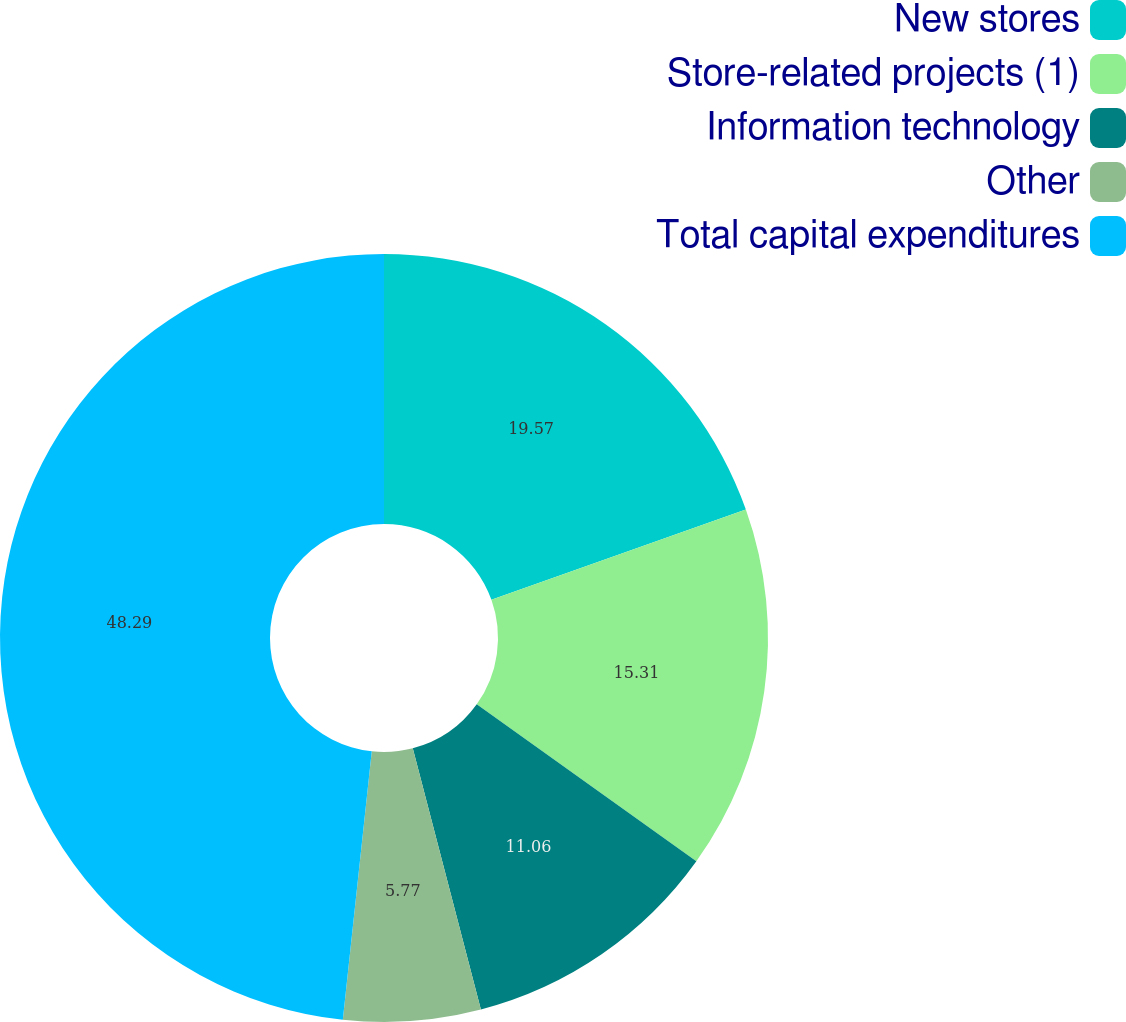<chart> <loc_0><loc_0><loc_500><loc_500><pie_chart><fcel>New stores<fcel>Store-related projects (1)<fcel>Information technology<fcel>Other<fcel>Total capital expenditures<nl><fcel>19.57%<fcel>15.31%<fcel>11.06%<fcel>5.77%<fcel>48.29%<nl></chart> 